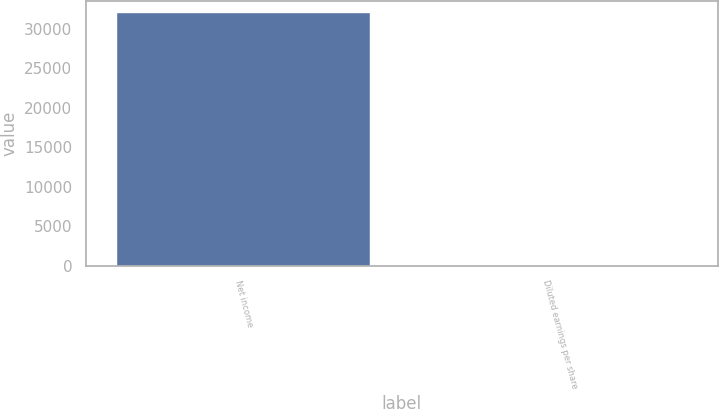Convert chart. <chart><loc_0><loc_0><loc_500><loc_500><bar_chart><fcel>Net income<fcel>Diluted earnings per share<nl><fcel>31963<fcel>0.44<nl></chart> 